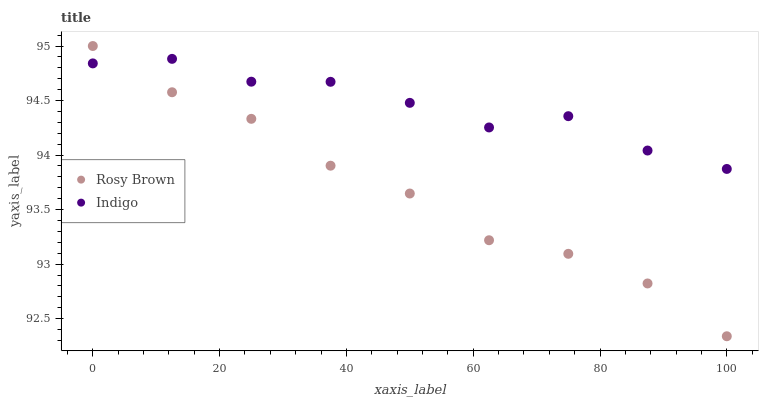Does Rosy Brown have the minimum area under the curve?
Answer yes or no. Yes. Does Indigo have the maximum area under the curve?
Answer yes or no. Yes. Does Indigo have the minimum area under the curve?
Answer yes or no. No. Is Rosy Brown the smoothest?
Answer yes or no. Yes. Is Indigo the roughest?
Answer yes or no. Yes. Is Indigo the smoothest?
Answer yes or no. No. Does Rosy Brown have the lowest value?
Answer yes or no. Yes. Does Indigo have the lowest value?
Answer yes or no. No. Does Rosy Brown have the highest value?
Answer yes or no. Yes. Does Indigo have the highest value?
Answer yes or no. No. Does Indigo intersect Rosy Brown?
Answer yes or no. Yes. Is Indigo less than Rosy Brown?
Answer yes or no. No. Is Indigo greater than Rosy Brown?
Answer yes or no. No. 